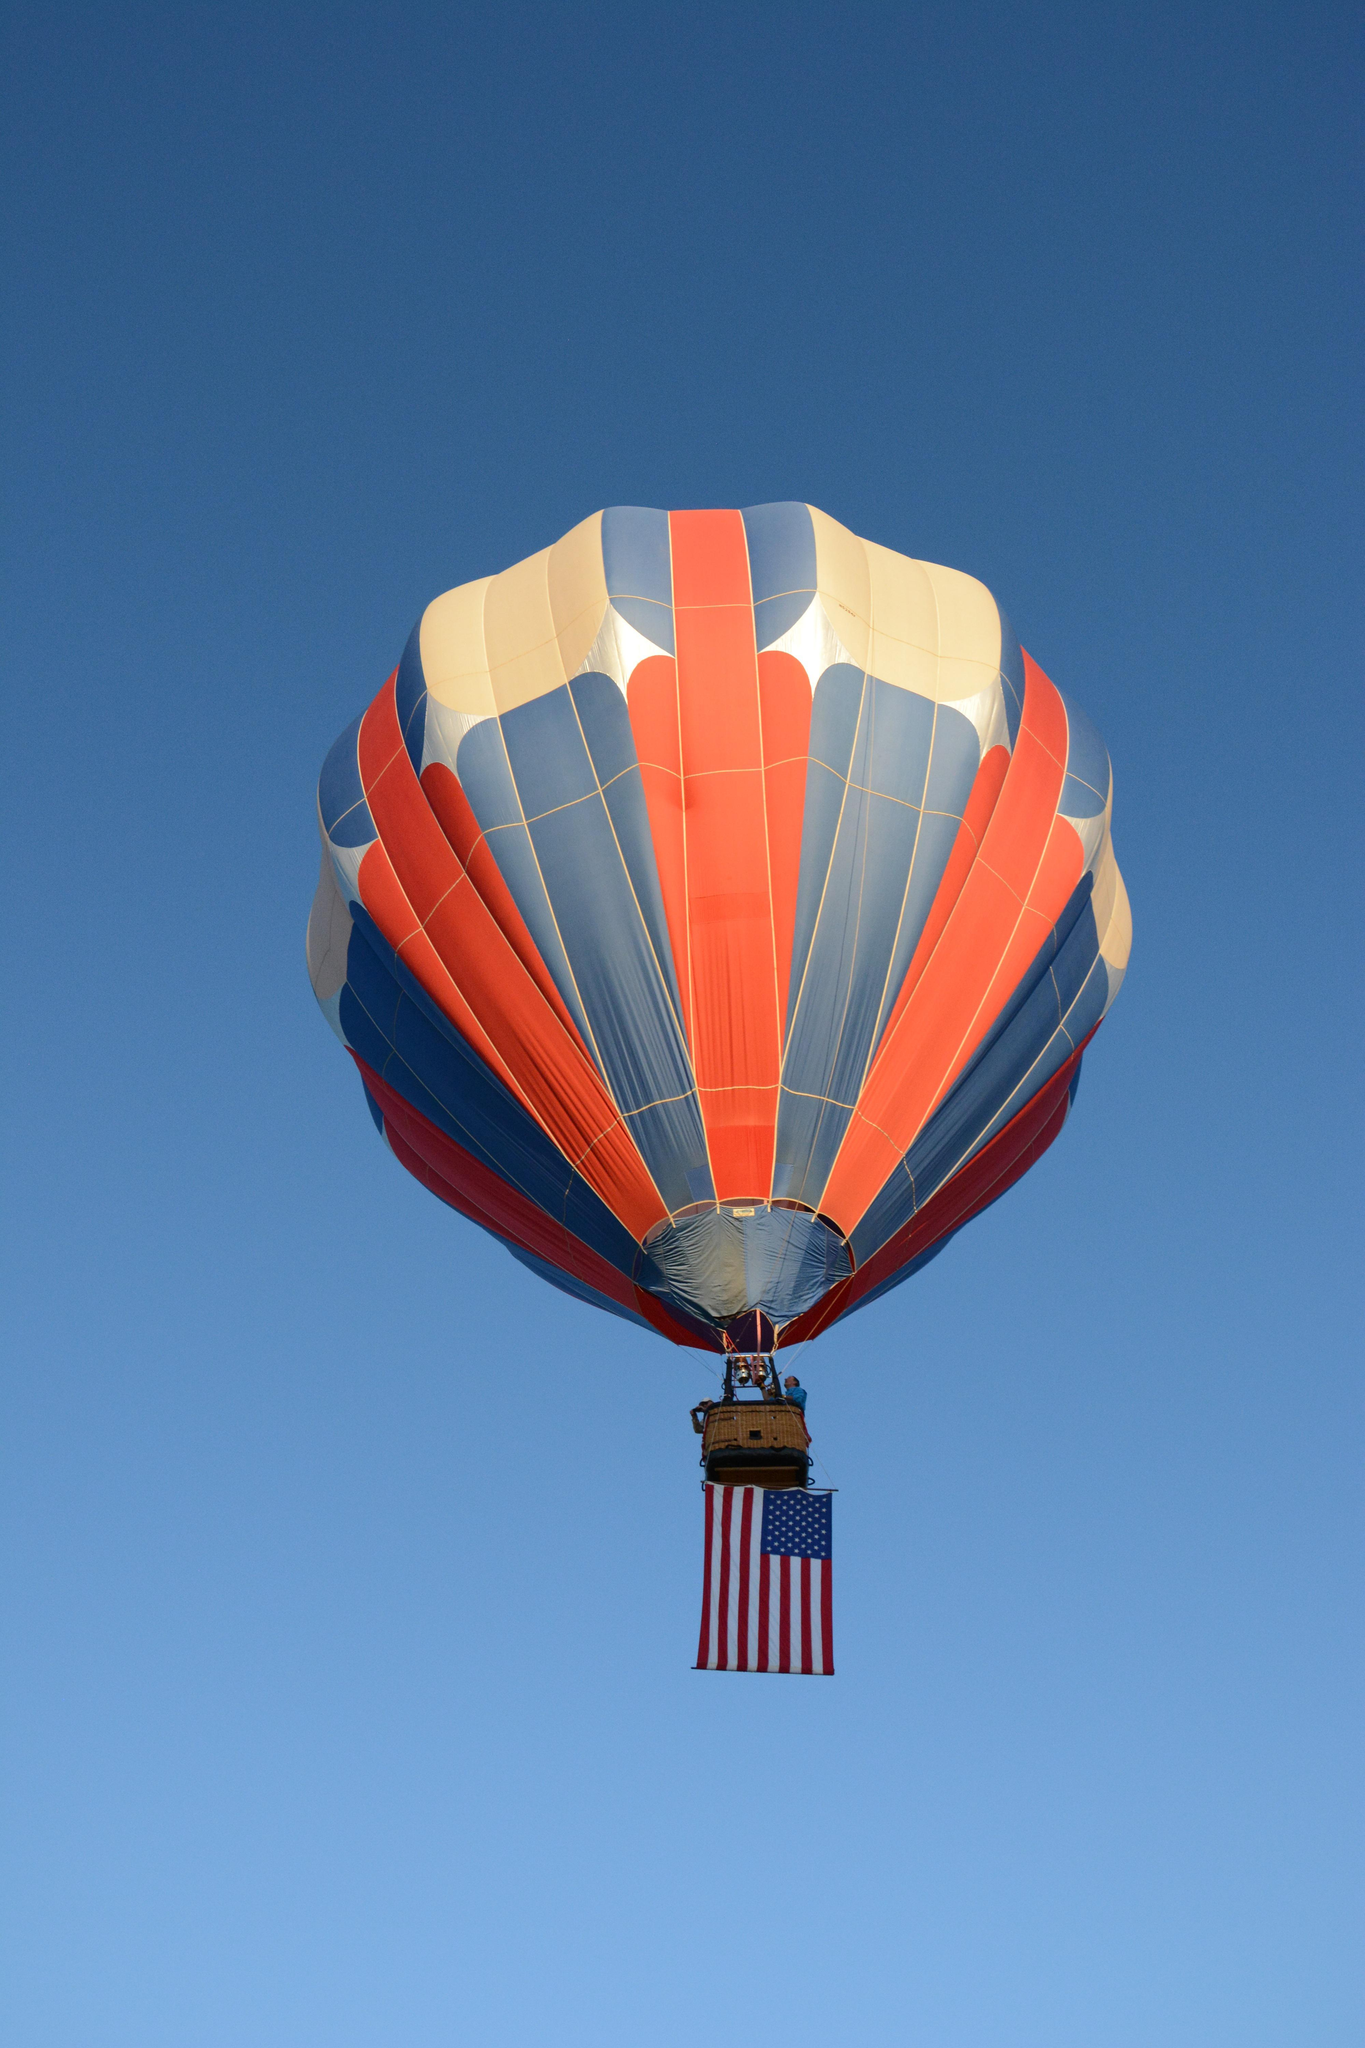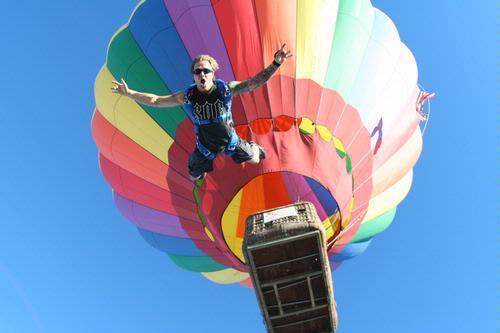The first image is the image on the left, the second image is the image on the right. For the images shown, is this caption "There is a skydiver in the image on the right." true? Answer yes or no. Yes. 